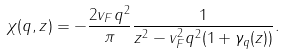<formula> <loc_0><loc_0><loc_500><loc_500>\chi ( q , z ) = - \frac { 2 v _ { F } q ^ { 2 } } { \pi } \frac { 1 } { z ^ { 2 } - v _ { F } ^ { 2 } q ^ { 2 } ( 1 + \gamma _ { q } ( z ) ) } .</formula> 